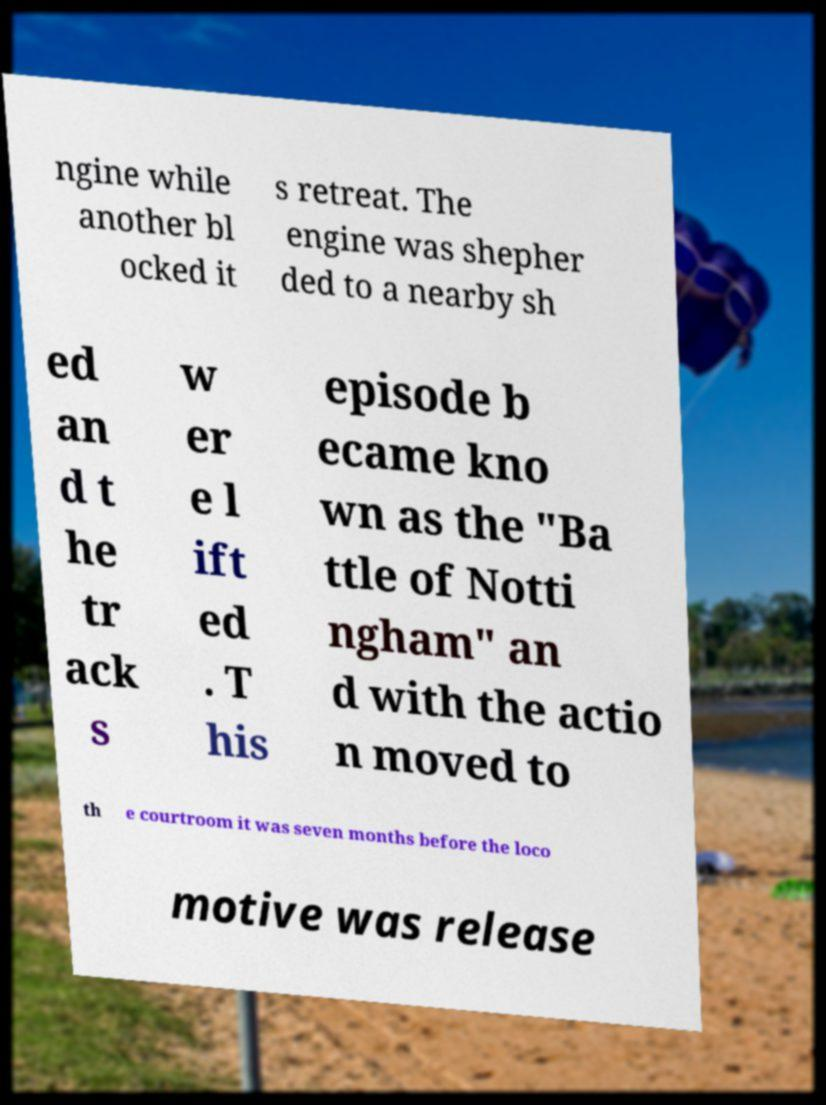Can you read and provide the text displayed in the image?This photo seems to have some interesting text. Can you extract and type it out for me? ngine while another bl ocked it s retreat. The engine was shepher ded to a nearby sh ed an d t he tr ack s w er e l ift ed . T his episode b ecame kno wn as the "Ba ttle of Notti ngham" an d with the actio n moved to th e courtroom it was seven months before the loco motive was release 